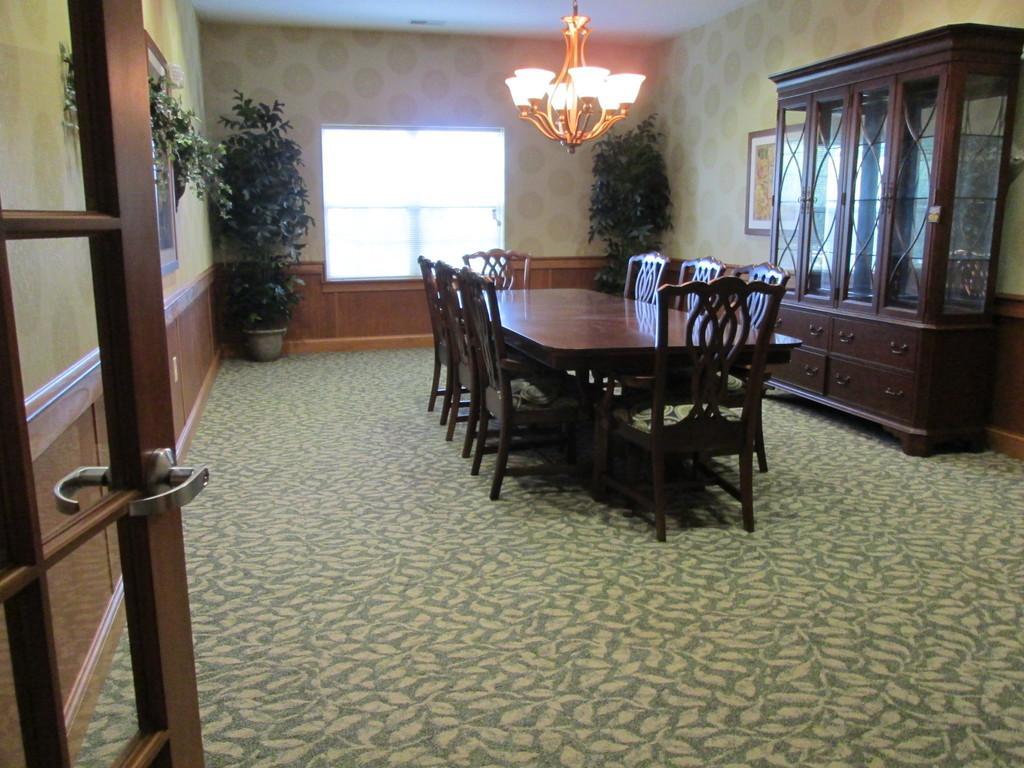Describe this image in one or two sentences. In this image I can see there is a table and there are a few chairs, there is a wooden shelf at right side and there is a window in the background. 